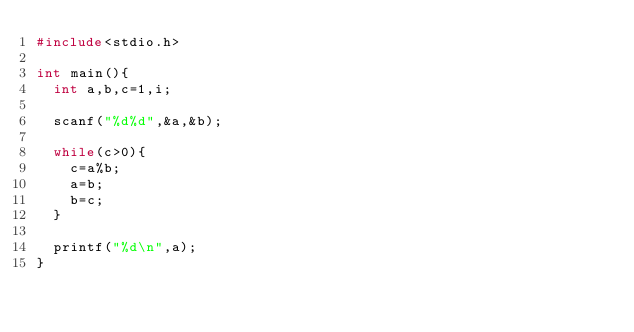<code> <loc_0><loc_0><loc_500><loc_500><_C_>#include<stdio.h>

int main(){
  int a,b,c=1,i;

  scanf("%d%d",&a,&b);

  while(c>0){
    c=a%b;
    a=b;
    b=c;
  }

  printf("%d\n",a);
}

</code> 